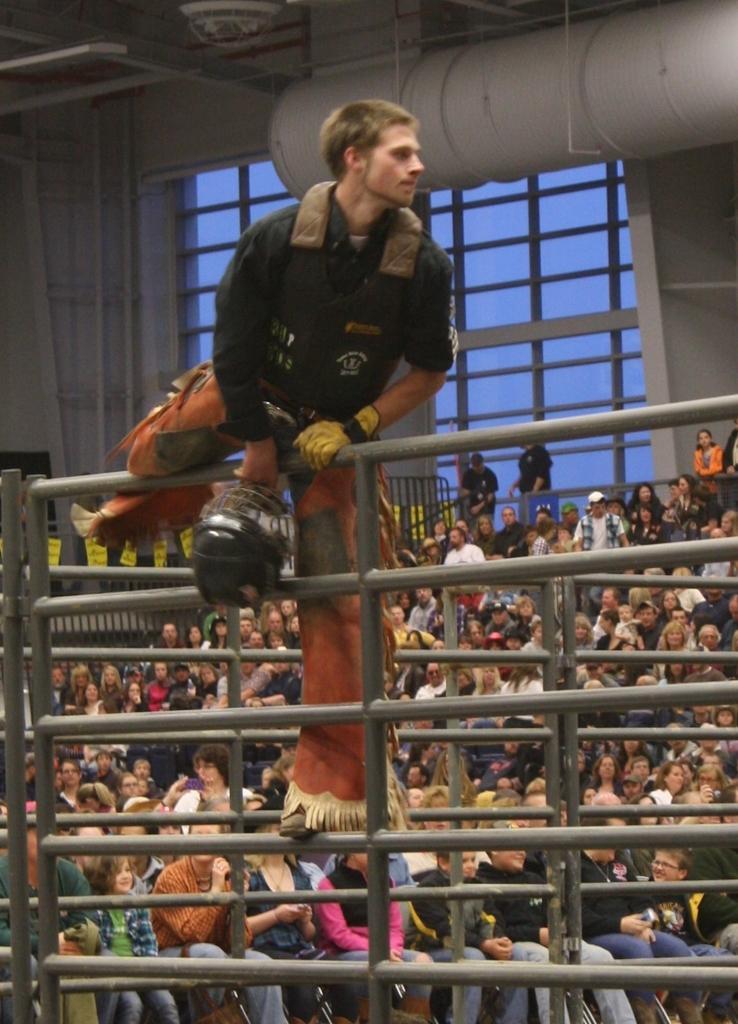Please provide a concise description of this image. In the center of the image we can see a man is standing on the rods and wearing jacket, glove and holding a helmet. In the background of the image we can see a group of people are sitting and also we can see the railing, papers, wall, window. At the top of the image we can see the roof and pipe. 